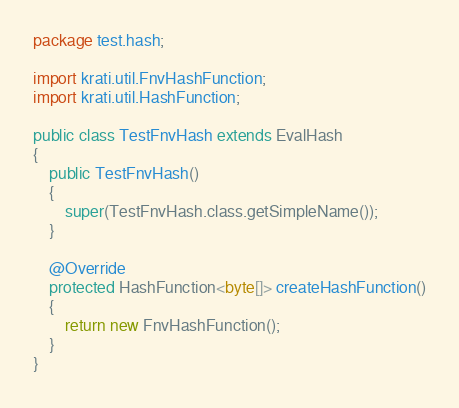<code> <loc_0><loc_0><loc_500><loc_500><_Java_>package test.hash;

import krati.util.FnvHashFunction;
import krati.util.HashFunction;

public class TestFnvHash extends EvalHash
{
    public TestFnvHash()
    {
        super(TestFnvHash.class.getSimpleName());
    }

    @Override
    protected HashFunction<byte[]> createHashFunction()
    {
        return new FnvHashFunction();
    }
}
</code> 